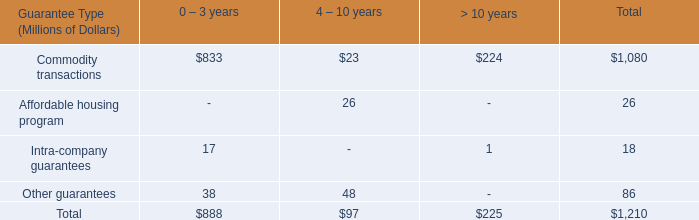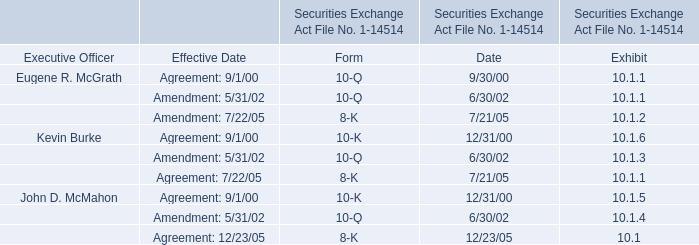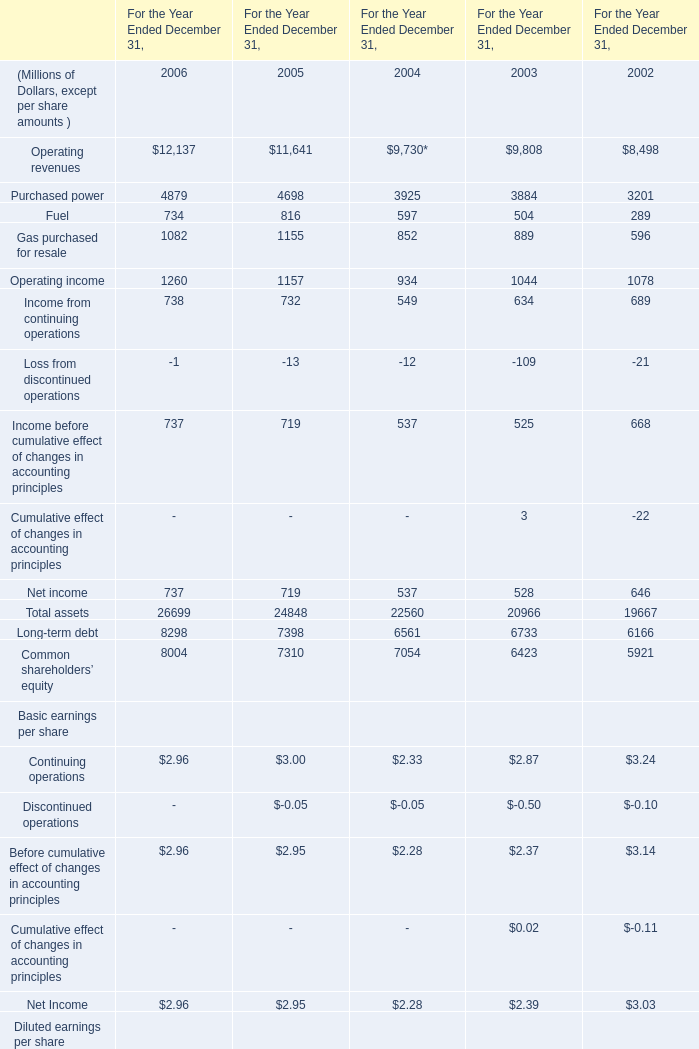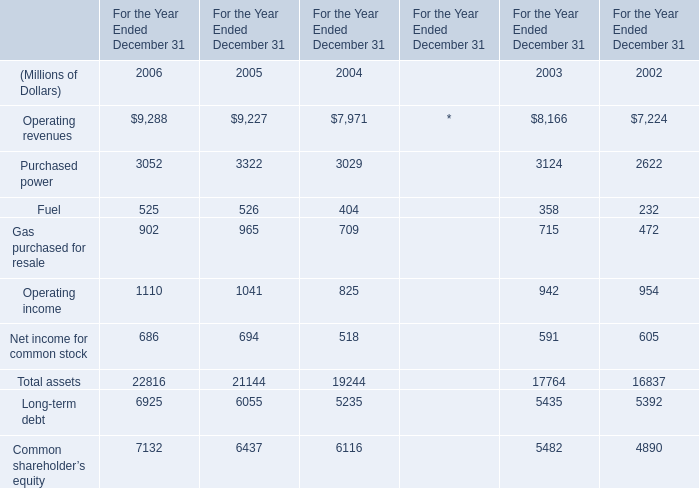What's the total amount of the Purchased power in the years where Operating revenues greater than 9000? (in Million) 
Computations: (3052 + 3322)
Answer: 6374.0. 